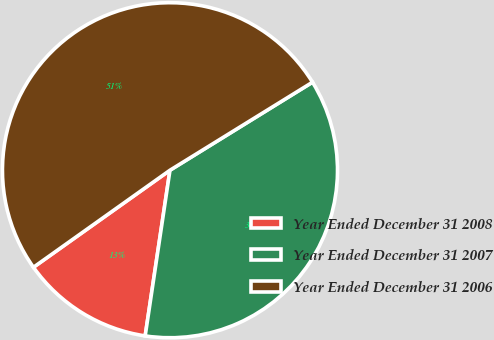Convert chart. <chart><loc_0><loc_0><loc_500><loc_500><pie_chart><fcel>Year Ended December 31 2008<fcel>Year Ended December 31 2007<fcel>Year Ended December 31 2006<nl><fcel>12.8%<fcel>36.17%<fcel>51.03%<nl></chart> 